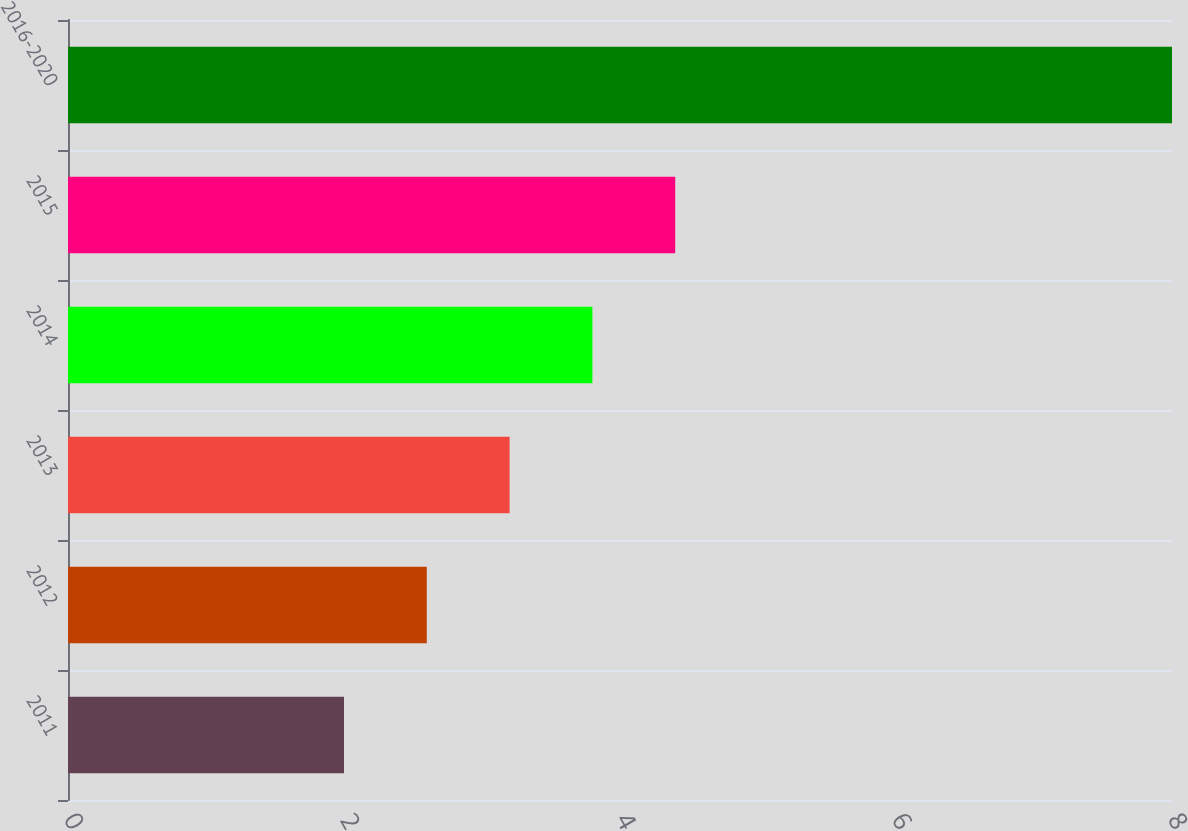<chart> <loc_0><loc_0><loc_500><loc_500><bar_chart><fcel>2011<fcel>2012<fcel>2013<fcel>2014<fcel>2015<fcel>2016-2020<nl><fcel>2<fcel>2.6<fcel>3.2<fcel>3.8<fcel>4.4<fcel>8<nl></chart> 